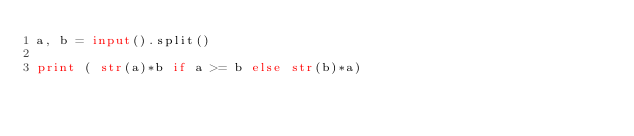<code> <loc_0><loc_0><loc_500><loc_500><_Python_>a, b = input().split()

print ( str(a)*b if a >= b else str(b)*a) </code> 